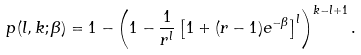Convert formula to latex. <formula><loc_0><loc_0><loc_500><loc_500>p ( l , k ; \beta ) = 1 - \left ( 1 - \frac { 1 } { r ^ { l } } \left [ 1 + ( r - 1 ) e ^ { - \beta } \right ] ^ { l } \right ) ^ { k - l + 1 } .</formula> 